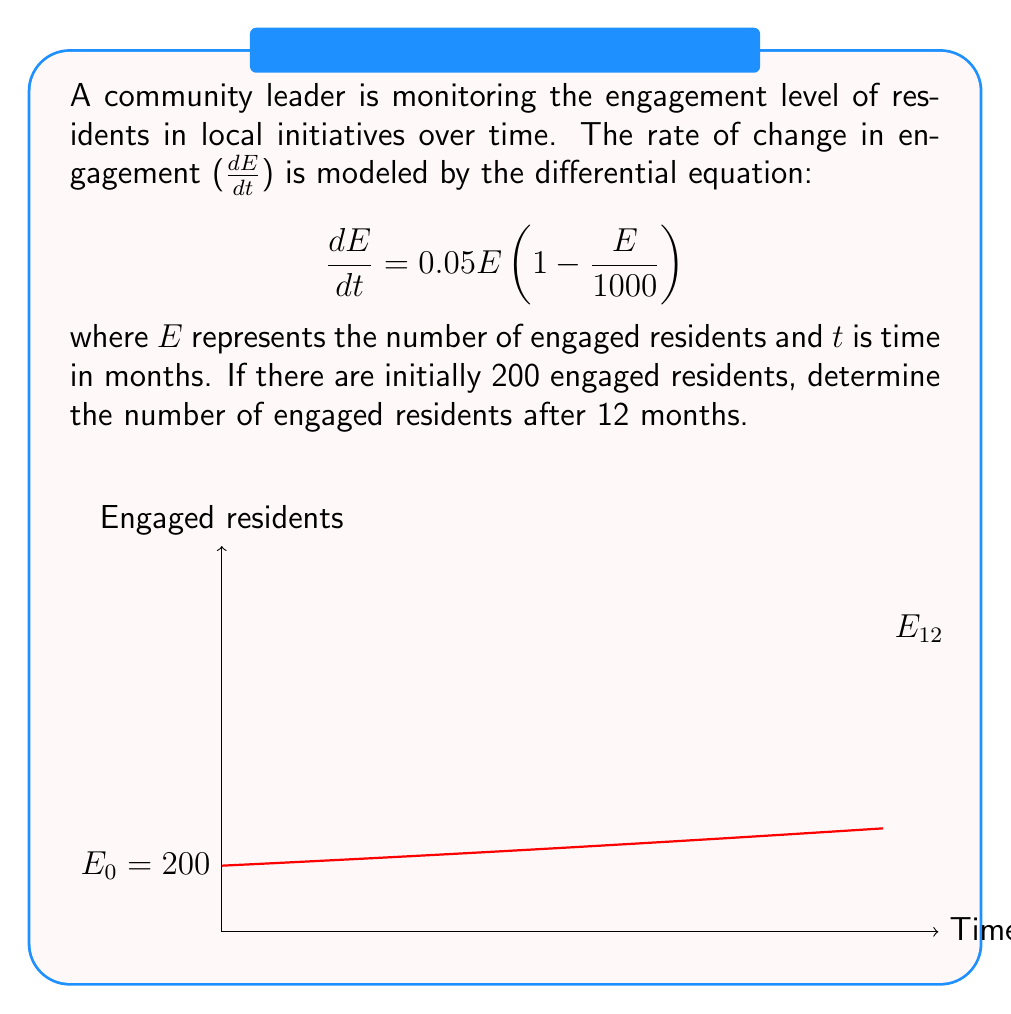Help me with this question. To solve this problem, we need to follow these steps:

1) Recognize that this is a logistic growth model with carrying capacity $K = 1000$ and growth rate $r = 0.05$.

2) The general solution for the logistic growth model is:

   $$E(t) = \frac{K}{1 + (\frac{K}{E_0} - 1)e^{-rt}}$$

   where $E_0$ is the initial number of engaged residents.

3) Substitute the given values:
   $K = 1000$, $r = 0.05$, $E_0 = 200$, $t = 12$

4) Calculate:

   $$E(12) = \frac{1000}{1 + (\frac{1000}{200} - 1)e^{-0.05(12)}}$$

5) Simplify:

   $$E(12) = \frac{1000}{1 + 4e^{-0.6}}$$

6) Calculate the final value:

   $$E(12) \approx 431.86$$

7) Round to the nearest whole number as we're dealing with people:

   $$E(12) \approx 432$$

This result shows a steady increase in engagement over time, aligning with the community leader's approach of slow and steady progress.
Answer: 432 engaged residents 